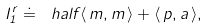<formula> <loc_0><loc_0><loc_500><loc_500>I _ { 1 } ^ { r } \doteq \ h a l f \langle \, { m } , { m } \, \rangle + \langle \, { p } , { a } \, \rangle ,</formula> 